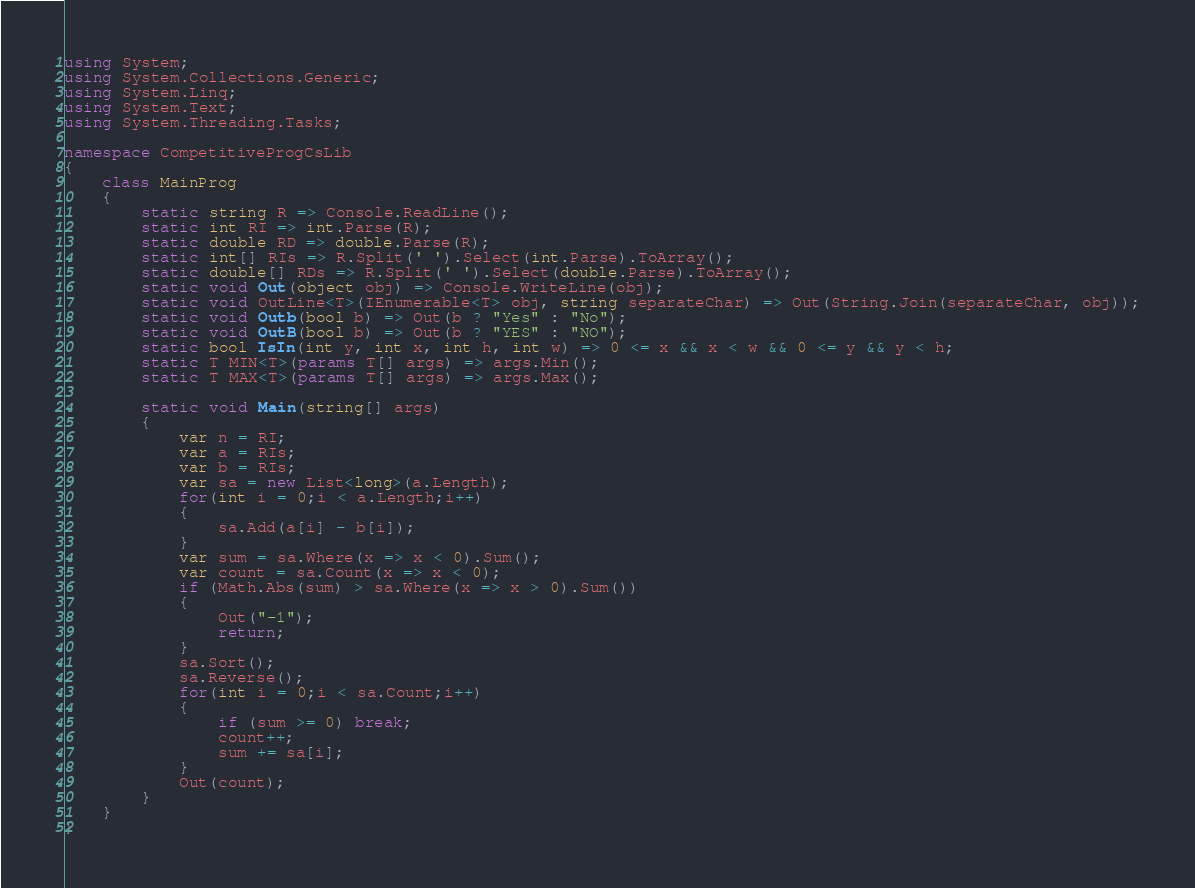<code> <loc_0><loc_0><loc_500><loc_500><_C#_>using System;
using System.Collections.Generic;
using System.Linq;
using System.Text;
using System.Threading.Tasks;

namespace CompetitiveProgCsLib
{
	class MainProg
	{
		static string R => Console.ReadLine();
		static int RI => int.Parse(R);
		static double RD => double.Parse(R);
		static int[] RIs => R.Split(' ').Select(int.Parse).ToArray();
		static double[] RDs => R.Split(' ').Select(double.Parse).ToArray();
		static void Out(object obj) => Console.WriteLine(obj);
		static void OutLine<T>(IEnumerable<T> obj, string separateChar) => Out(String.Join(separateChar, obj));
		static void Outb(bool b) => Out(b ? "Yes" : "No");
		static void OutB(bool b) => Out(b ? "YES" : "NO");
		static bool IsIn(int y, int x, int h, int w) => 0 <= x && x < w && 0 <= y && y < h;
		static T MIN<T>(params T[] args) => args.Min();
		static T MAX<T>(params T[] args) => args.Max();

		static void Main(string[] args)
		{
			var n = RI;
			var a = RIs;
			var b = RIs;
			var sa = new List<long>(a.Length);
			for(int i = 0;i < a.Length;i++)
			{
				sa.Add(a[i] - b[i]);
			}
			var sum = sa.Where(x => x < 0).Sum();
			var count = sa.Count(x => x < 0);
			if (Math.Abs(sum) > sa.Where(x => x > 0).Sum())
			{
				Out("-1");
				return;
			}
			sa.Sort();
			sa.Reverse();
			for(int i = 0;i < sa.Count;i++)
			{
				if (sum >= 0) break;
				count++;
				sum += sa[i];
			}
			Out(count);
		}
	}
}
</code> 